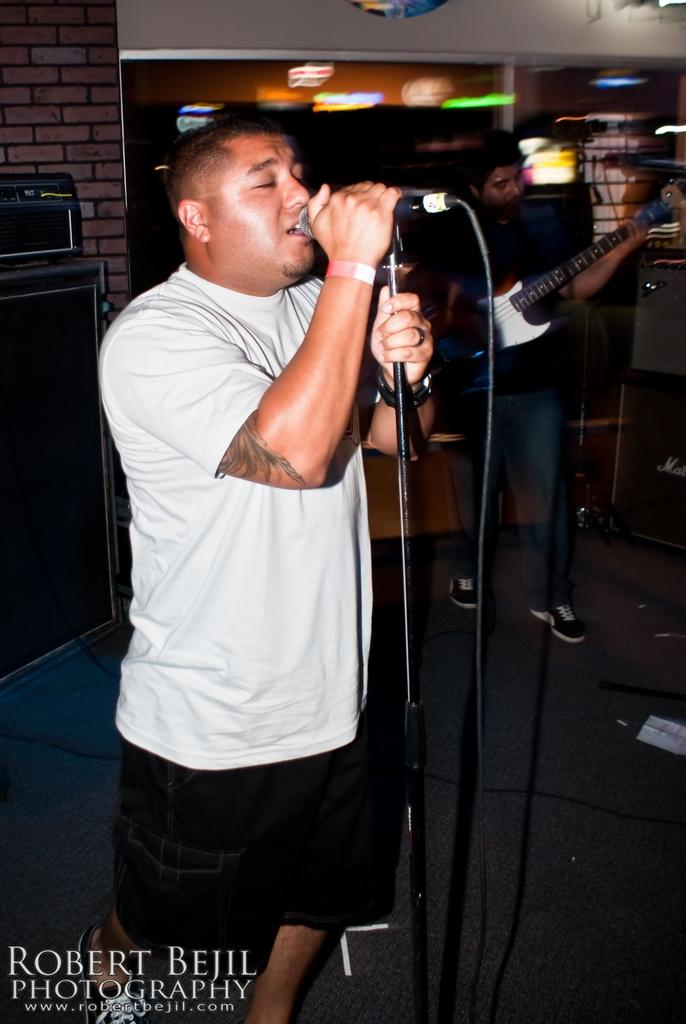How many people are in the image? There are two persons in the image. What is the person wearing a white shirt doing? The person in the white shirt is holding a mike stand. What is the other person holding? The other person is holding a guitar. What type of footwear is the person holding the guitar wearing? The person holding the guitar is wearing shoes. What type of discussion is happening between the two persons in the image? There is no discussion happening between the two persons in the image; they are holding a mike stand and a guitar, respectively. Can you tell me how many coughs the person holding the guitar has in the image? There is no coughing happening in the image, and therefore no coughs can be counted. 